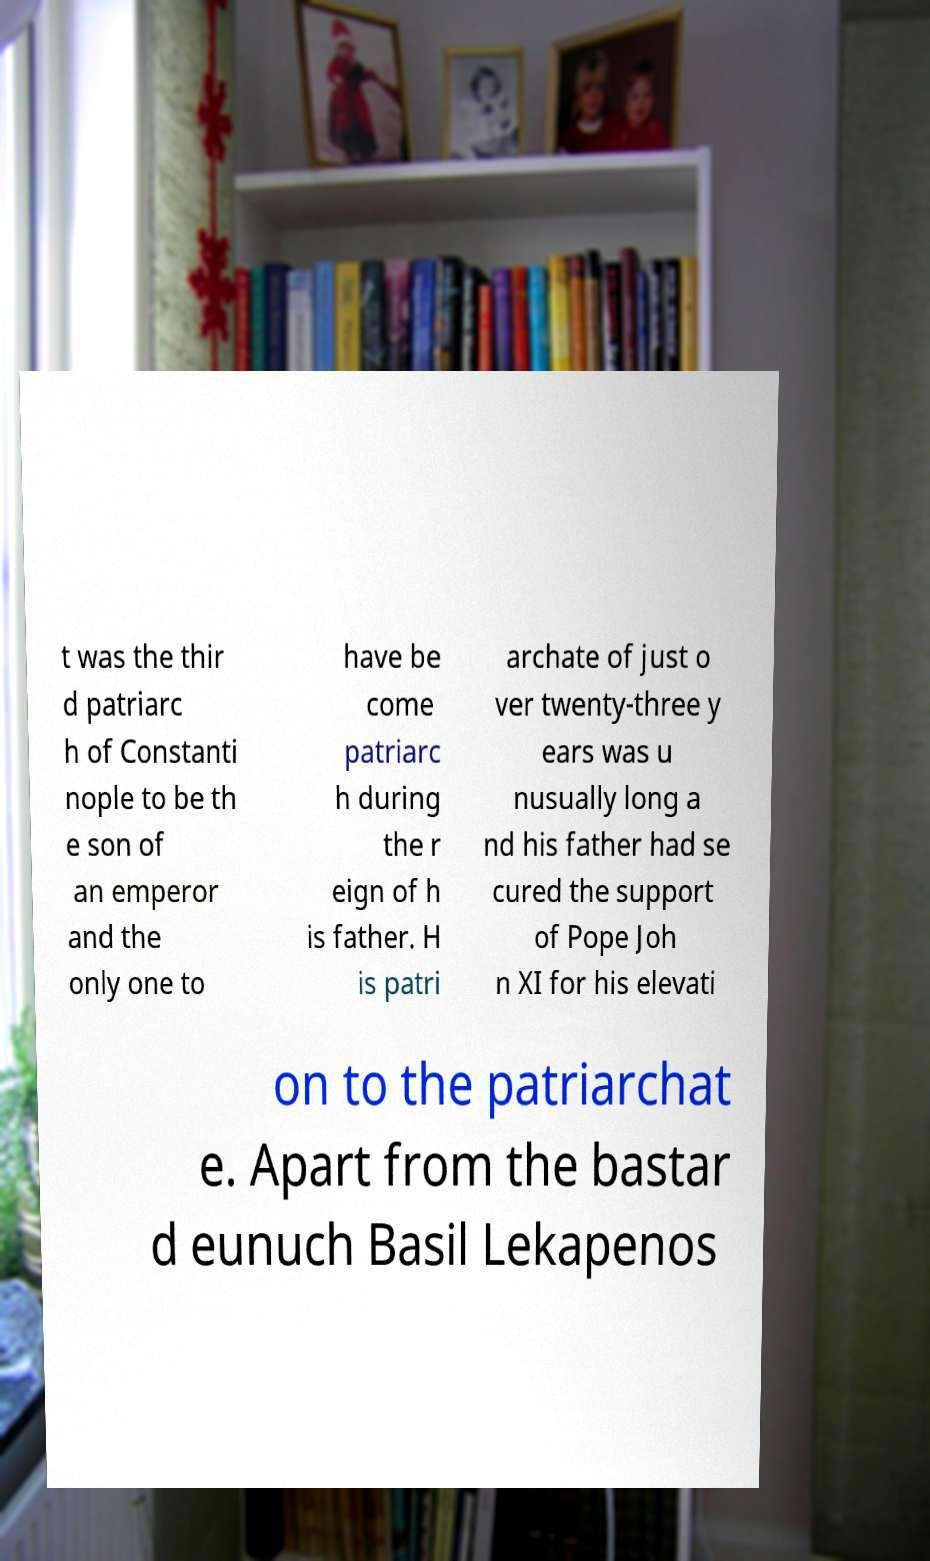Could you extract and type out the text from this image? t was the thir d patriarc h of Constanti nople to be th e son of an emperor and the only one to have be come patriarc h during the r eign of h is father. H is patri archate of just o ver twenty-three y ears was u nusually long a nd his father had se cured the support of Pope Joh n XI for his elevati on to the patriarchat e. Apart from the bastar d eunuch Basil Lekapenos 